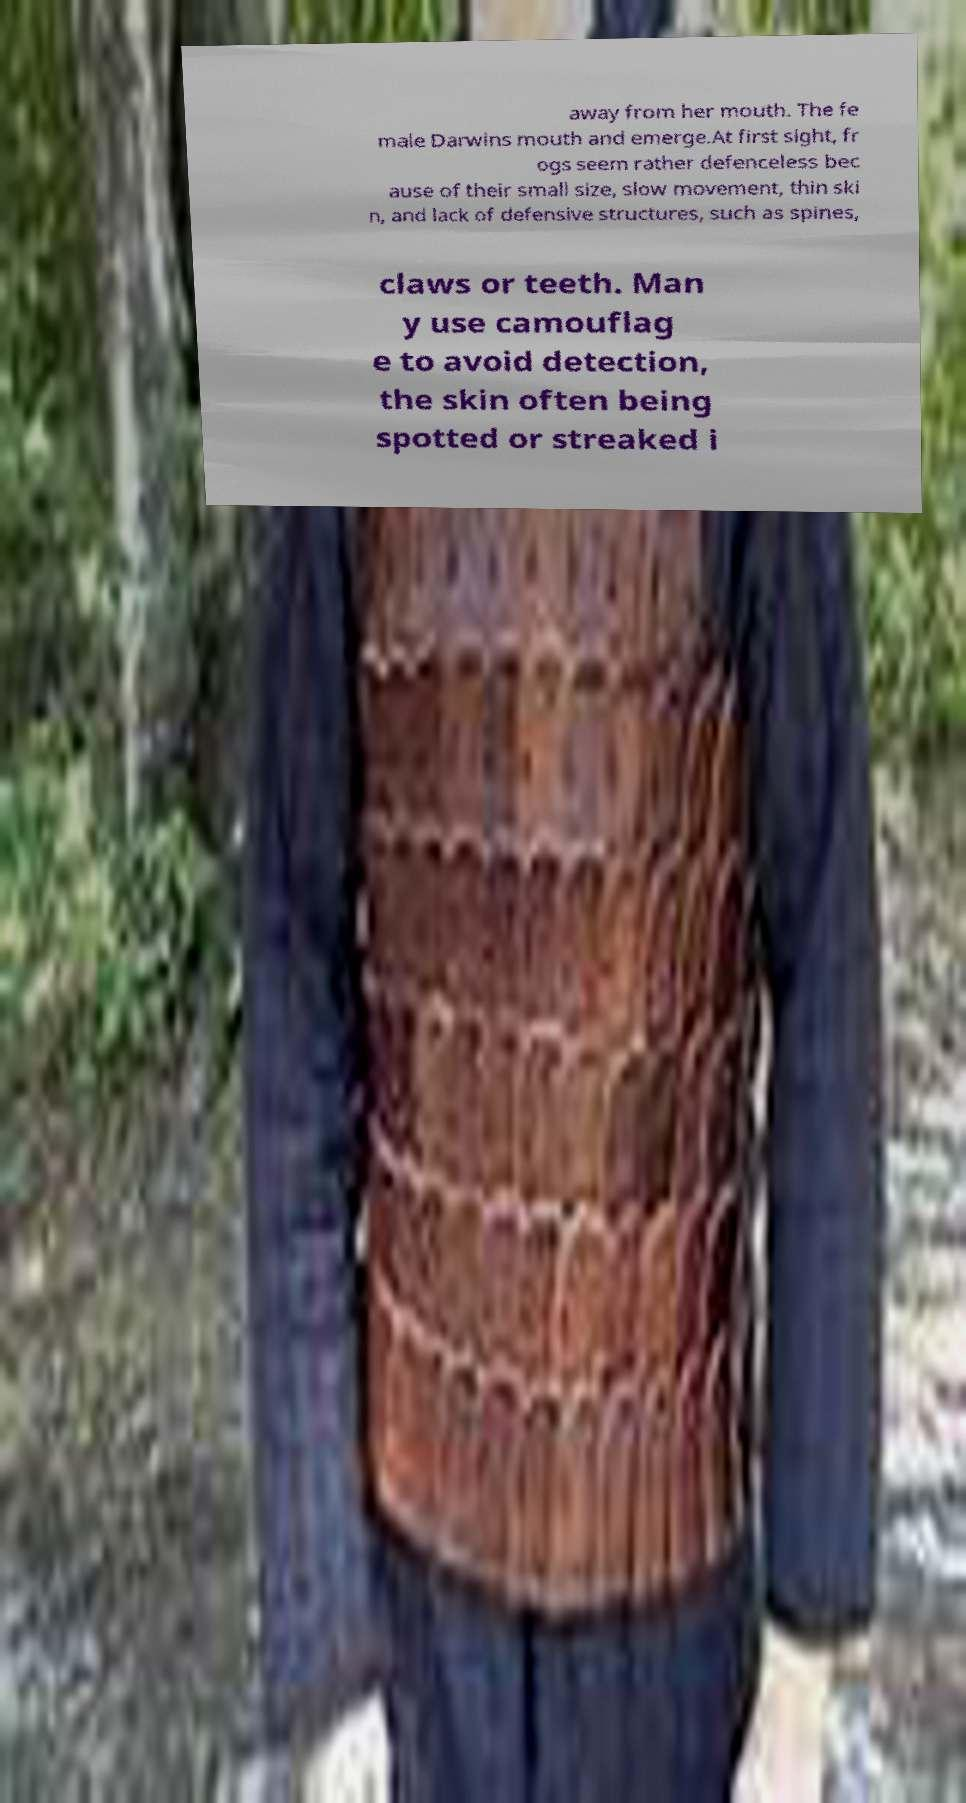There's text embedded in this image that I need extracted. Can you transcribe it verbatim? away from her mouth. The fe male Darwins mouth and emerge.At first sight, fr ogs seem rather defenceless bec ause of their small size, slow movement, thin ski n, and lack of defensive structures, such as spines, claws or teeth. Man y use camouflag e to avoid detection, the skin often being spotted or streaked i 